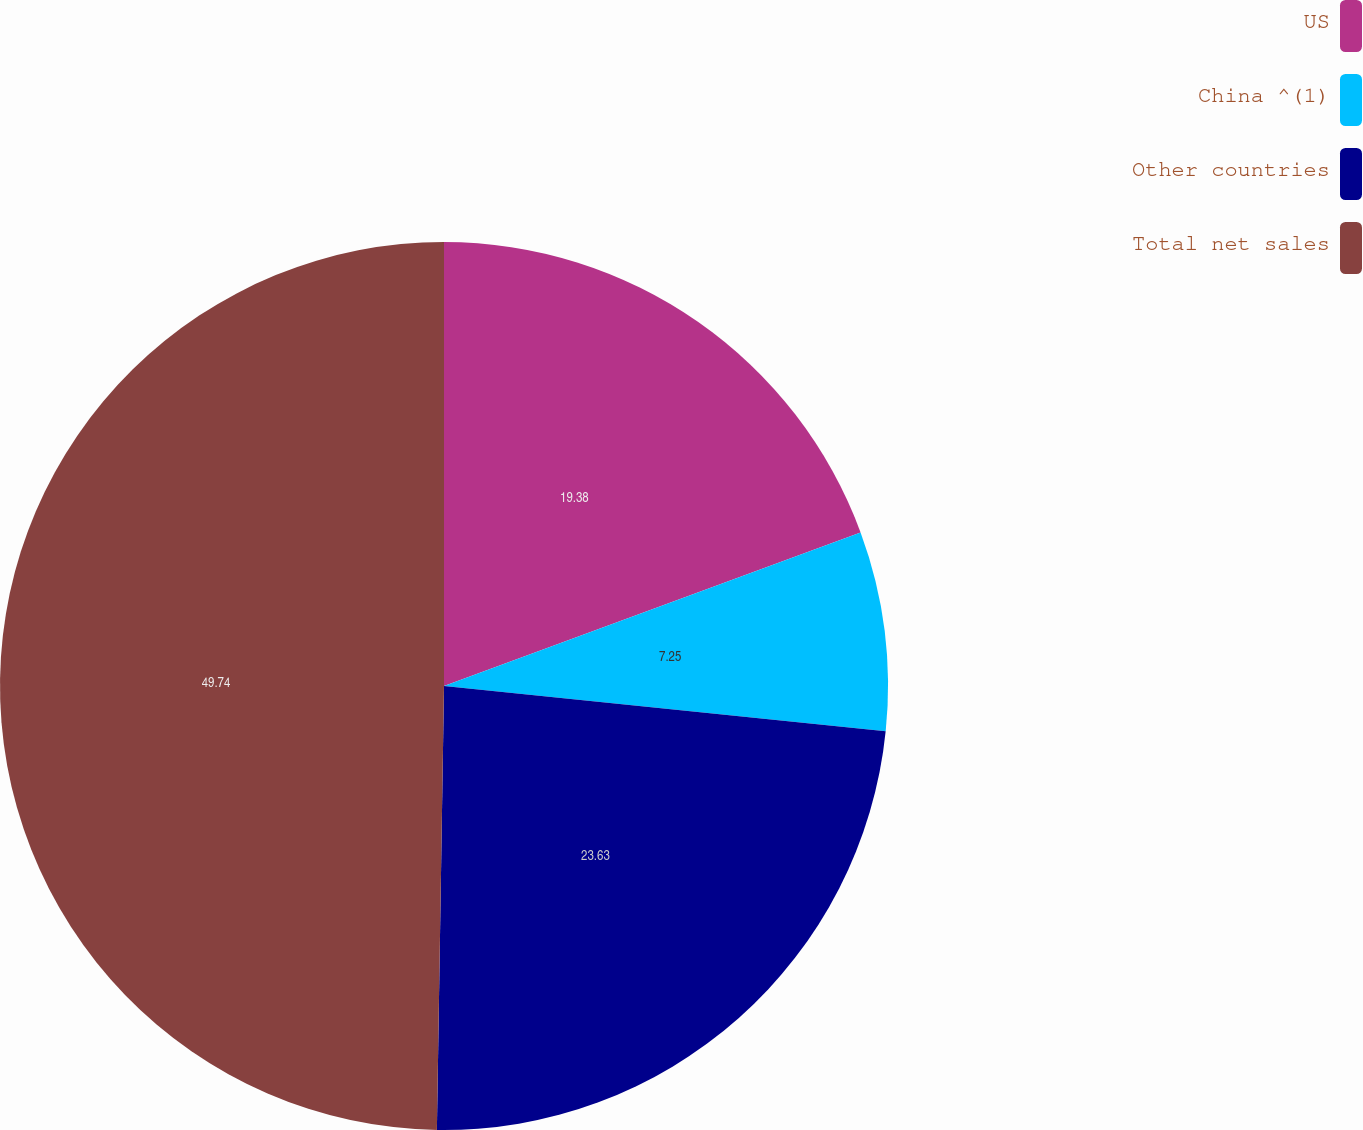Convert chart to OTSL. <chart><loc_0><loc_0><loc_500><loc_500><pie_chart><fcel>US<fcel>China ^(1)<fcel>Other countries<fcel>Total net sales<nl><fcel>19.38%<fcel>7.25%<fcel>23.63%<fcel>49.75%<nl></chart> 